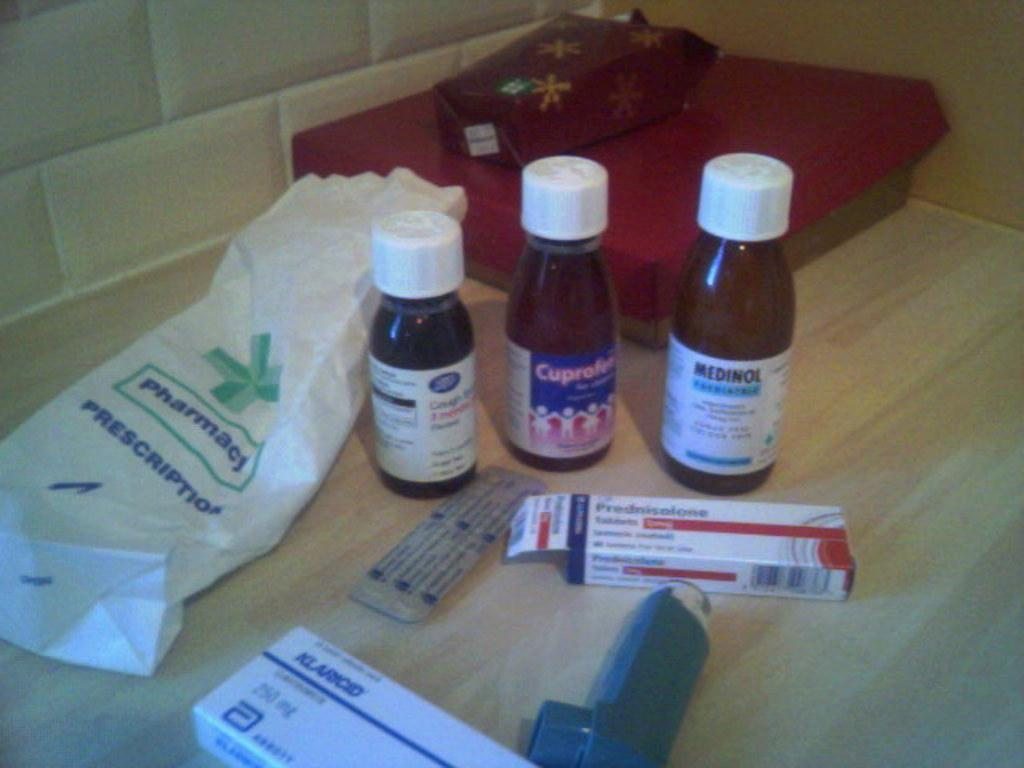<image>
Provide a brief description of the given image. An empty pharmacy bag is on the counter next to bottles of Medinol. Cuprofen, and cough medicine. 